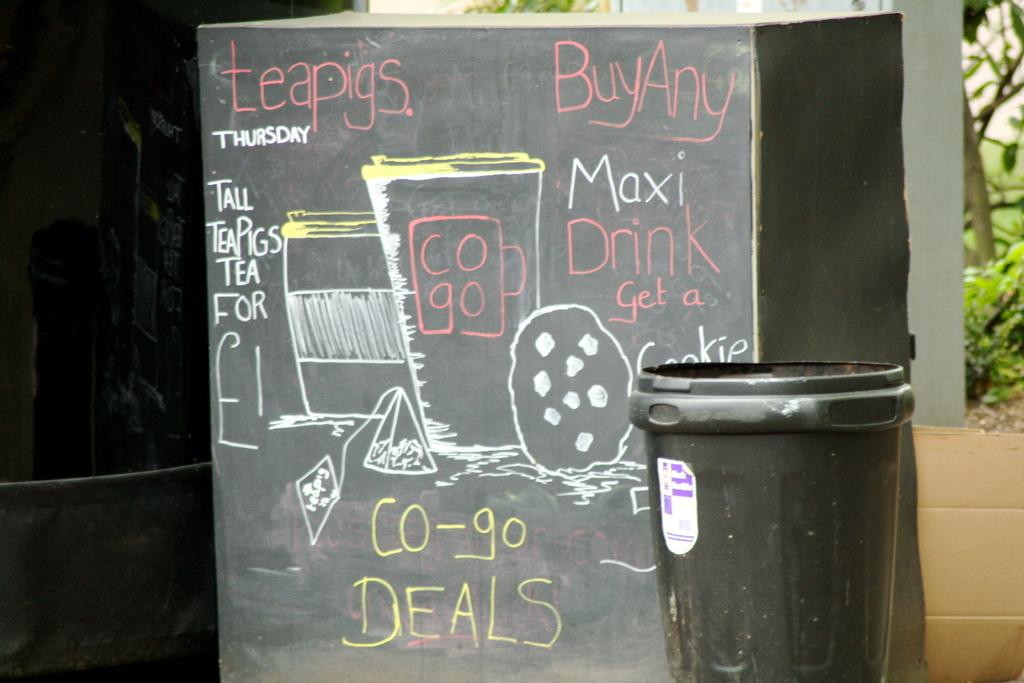What does the yellow text say?
Make the answer very short. Co-go deals. 